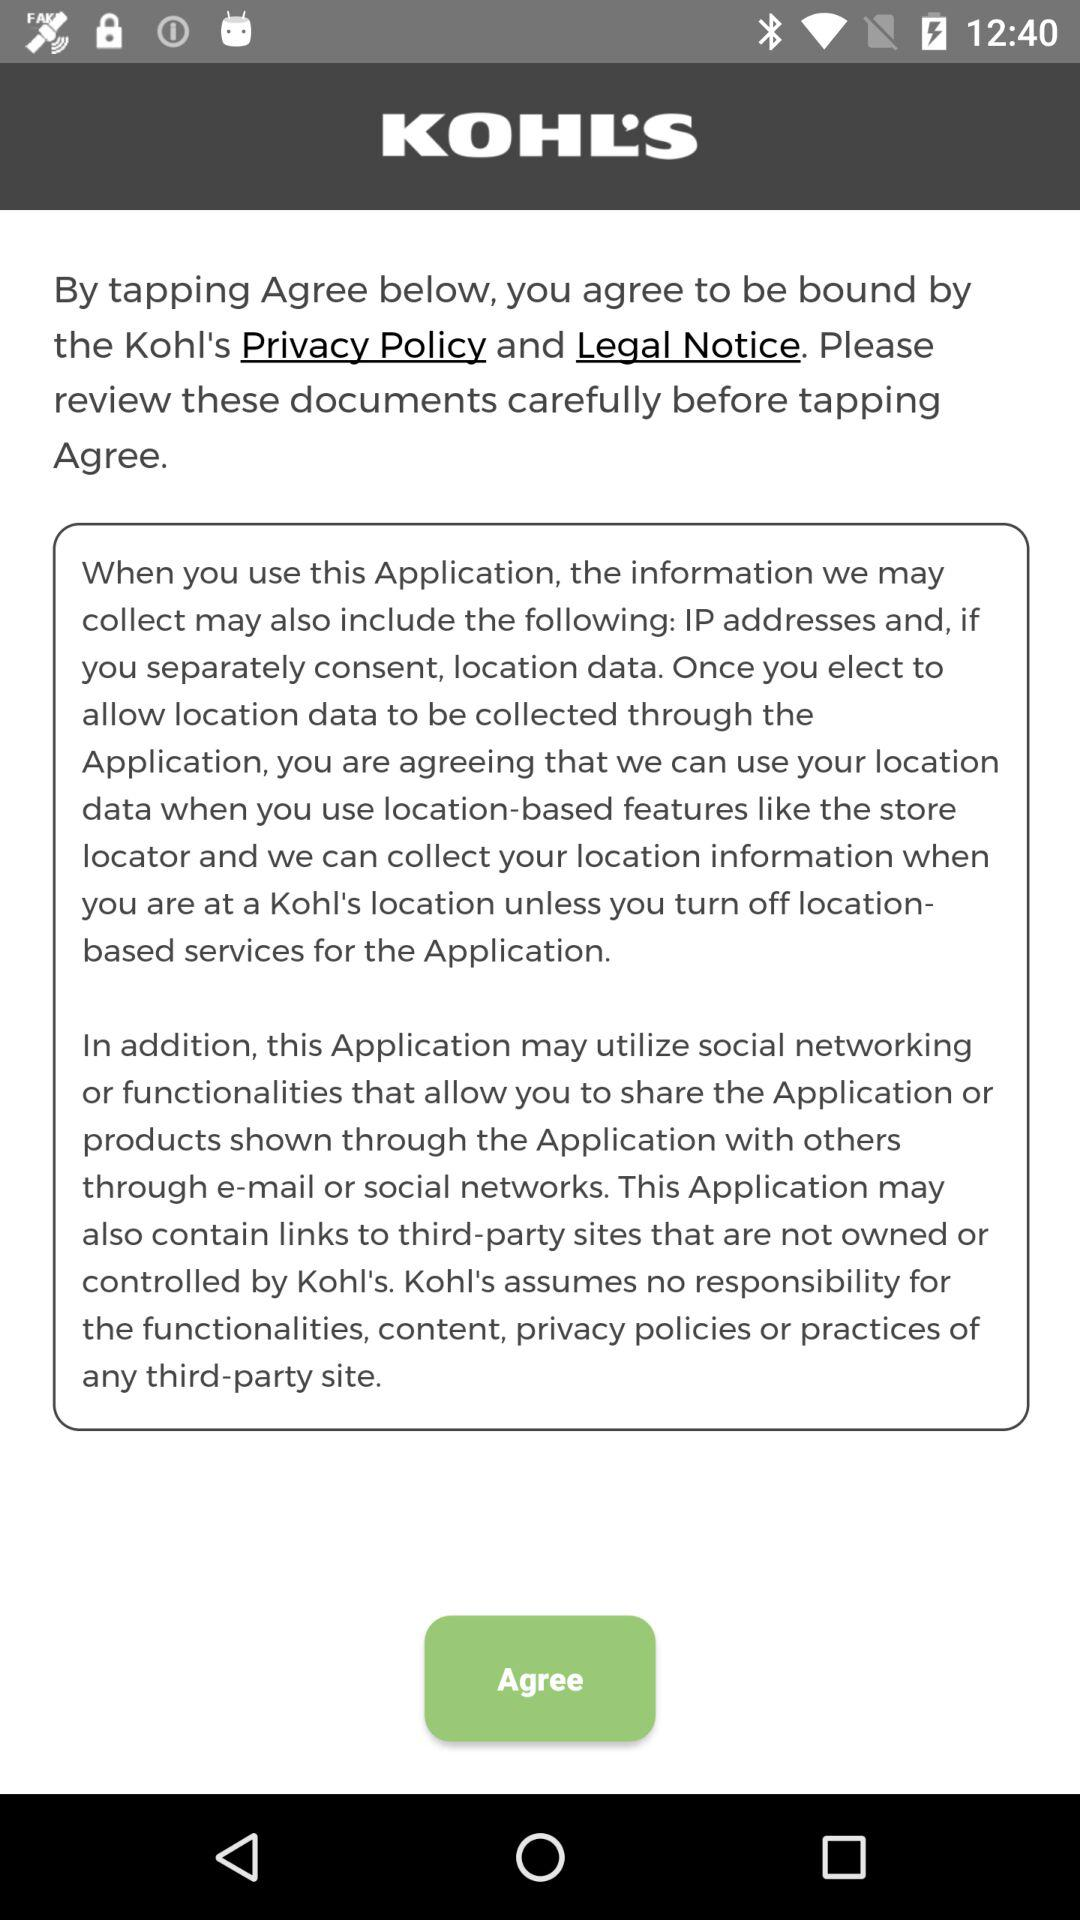How many documents are mentioned in the terms and conditions?
Answer the question using a single word or phrase. 2 